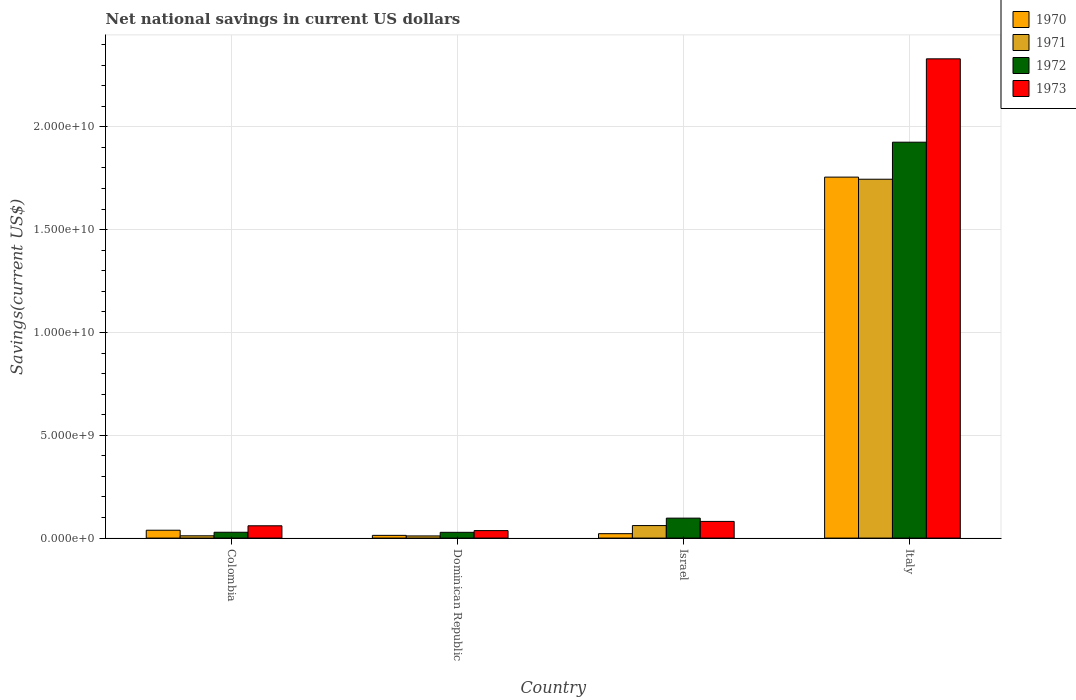How many different coloured bars are there?
Keep it short and to the point. 4. Are the number of bars on each tick of the X-axis equal?
Provide a succinct answer. Yes. How many bars are there on the 3rd tick from the left?
Give a very brief answer. 4. What is the net national savings in 1970 in Colombia?
Your answer should be very brief. 3.83e+08. Across all countries, what is the maximum net national savings in 1970?
Make the answer very short. 1.76e+1. Across all countries, what is the minimum net national savings in 1971?
Offer a very short reply. 1.05e+08. In which country was the net national savings in 1972 maximum?
Provide a succinct answer. Italy. In which country was the net national savings in 1973 minimum?
Provide a short and direct response. Dominican Republic. What is the total net national savings in 1973 in the graph?
Your answer should be very brief. 2.51e+1. What is the difference between the net national savings in 1972 in Colombia and that in Israel?
Offer a terse response. -6.87e+08. What is the difference between the net national savings in 1972 in Colombia and the net national savings in 1970 in Italy?
Your answer should be very brief. -1.73e+1. What is the average net national savings in 1971 per country?
Provide a succinct answer. 4.57e+09. What is the difference between the net national savings of/in 1971 and net national savings of/in 1973 in Dominican Republic?
Your answer should be compact. -2.59e+08. What is the ratio of the net national savings in 1971 in Colombia to that in Israel?
Your response must be concise. 0.18. Is the difference between the net national savings in 1971 in Dominican Republic and Italy greater than the difference between the net national savings in 1973 in Dominican Republic and Italy?
Offer a very short reply. Yes. What is the difference between the highest and the second highest net national savings in 1971?
Provide a succinct answer. 1.68e+1. What is the difference between the highest and the lowest net national savings in 1970?
Make the answer very short. 1.74e+1. What does the 2nd bar from the right in Dominican Republic represents?
Make the answer very short. 1972. Is it the case that in every country, the sum of the net national savings in 1972 and net national savings in 1970 is greater than the net national savings in 1973?
Make the answer very short. Yes. Does the graph contain grids?
Keep it short and to the point. Yes. How are the legend labels stacked?
Provide a short and direct response. Vertical. What is the title of the graph?
Keep it short and to the point. Net national savings in current US dollars. Does "1970" appear as one of the legend labels in the graph?
Keep it short and to the point. Yes. What is the label or title of the Y-axis?
Your answer should be compact. Savings(current US$). What is the Savings(current US$) in 1970 in Colombia?
Offer a very short reply. 3.83e+08. What is the Savings(current US$) in 1971 in Colombia?
Your answer should be compact. 1.11e+08. What is the Savings(current US$) of 1972 in Colombia?
Make the answer very short. 2.84e+08. What is the Savings(current US$) of 1973 in Colombia?
Keep it short and to the point. 5.98e+08. What is the Savings(current US$) of 1970 in Dominican Republic?
Provide a succinct answer. 1.33e+08. What is the Savings(current US$) of 1971 in Dominican Republic?
Keep it short and to the point. 1.05e+08. What is the Savings(current US$) of 1972 in Dominican Republic?
Your answer should be compact. 2.80e+08. What is the Savings(current US$) of 1973 in Dominican Republic?
Keep it short and to the point. 3.65e+08. What is the Savings(current US$) in 1970 in Israel?
Keep it short and to the point. 2.15e+08. What is the Savings(current US$) in 1971 in Israel?
Make the answer very short. 6.09e+08. What is the Savings(current US$) of 1972 in Israel?
Offer a terse response. 9.71e+08. What is the Savings(current US$) of 1973 in Israel?
Your answer should be compact. 8.11e+08. What is the Savings(current US$) of 1970 in Italy?
Your answer should be compact. 1.76e+1. What is the Savings(current US$) in 1971 in Italy?
Make the answer very short. 1.75e+1. What is the Savings(current US$) in 1972 in Italy?
Provide a succinct answer. 1.93e+1. What is the Savings(current US$) of 1973 in Italy?
Make the answer very short. 2.33e+1. Across all countries, what is the maximum Savings(current US$) in 1970?
Offer a very short reply. 1.76e+1. Across all countries, what is the maximum Savings(current US$) in 1971?
Your answer should be very brief. 1.75e+1. Across all countries, what is the maximum Savings(current US$) in 1972?
Your answer should be very brief. 1.93e+1. Across all countries, what is the maximum Savings(current US$) of 1973?
Provide a succinct answer. 2.33e+1. Across all countries, what is the minimum Savings(current US$) of 1970?
Your response must be concise. 1.33e+08. Across all countries, what is the minimum Savings(current US$) in 1971?
Make the answer very short. 1.05e+08. Across all countries, what is the minimum Savings(current US$) of 1972?
Your answer should be very brief. 2.80e+08. Across all countries, what is the minimum Savings(current US$) in 1973?
Provide a short and direct response. 3.65e+08. What is the total Savings(current US$) in 1970 in the graph?
Make the answer very short. 1.83e+1. What is the total Savings(current US$) in 1971 in the graph?
Make the answer very short. 1.83e+1. What is the total Savings(current US$) in 1972 in the graph?
Offer a terse response. 2.08e+1. What is the total Savings(current US$) of 1973 in the graph?
Your answer should be very brief. 2.51e+1. What is the difference between the Savings(current US$) in 1970 in Colombia and that in Dominican Republic?
Provide a short and direct response. 2.50e+08. What is the difference between the Savings(current US$) in 1971 in Colombia and that in Dominican Republic?
Your answer should be compact. 6.03e+06. What is the difference between the Savings(current US$) in 1972 in Colombia and that in Dominican Republic?
Provide a short and direct response. 3.48e+06. What is the difference between the Savings(current US$) of 1973 in Colombia and that in Dominican Republic?
Provide a short and direct response. 2.34e+08. What is the difference between the Savings(current US$) of 1970 in Colombia and that in Israel?
Your answer should be compact. 1.68e+08. What is the difference between the Savings(current US$) in 1971 in Colombia and that in Israel?
Keep it short and to the point. -4.97e+08. What is the difference between the Savings(current US$) in 1972 in Colombia and that in Israel?
Give a very brief answer. -6.87e+08. What is the difference between the Savings(current US$) in 1973 in Colombia and that in Israel?
Ensure brevity in your answer.  -2.12e+08. What is the difference between the Savings(current US$) in 1970 in Colombia and that in Italy?
Keep it short and to the point. -1.72e+1. What is the difference between the Savings(current US$) in 1971 in Colombia and that in Italy?
Ensure brevity in your answer.  -1.73e+1. What is the difference between the Savings(current US$) in 1972 in Colombia and that in Italy?
Ensure brevity in your answer.  -1.90e+1. What is the difference between the Savings(current US$) of 1973 in Colombia and that in Italy?
Keep it short and to the point. -2.27e+1. What is the difference between the Savings(current US$) in 1970 in Dominican Republic and that in Israel?
Ensure brevity in your answer.  -8.19e+07. What is the difference between the Savings(current US$) of 1971 in Dominican Republic and that in Israel?
Offer a very short reply. -5.03e+08. What is the difference between the Savings(current US$) of 1972 in Dominican Republic and that in Israel?
Keep it short and to the point. -6.90e+08. What is the difference between the Savings(current US$) of 1973 in Dominican Republic and that in Israel?
Provide a succinct answer. -4.46e+08. What is the difference between the Savings(current US$) in 1970 in Dominican Republic and that in Italy?
Your answer should be compact. -1.74e+1. What is the difference between the Savings(current US$) in 1971 in Dominican Republic and that in Italy?
Offer a very short reply. -1.73e+1. What is the difference between the Savings(current US$) of 1972 in Dominican Republic and that in Italy?
Ensure brevity in your answer.  -1.90e+1. What is the difference between the Savings(current US$) in 1973 in Dominican Republic and that in Italy?
Your answer should be very brief. -2.29e+1. What is the difference between the Savings(current US$) of 1970 in Israel and that in Italy?
Offer a terse response. -1.73e+1. What is the difference between the Savings(current US$) in 1971 in Israel and that in Italy?
Keep it short and to the point. -1.68e+1. What is the difference between the Savings(current US$) in 1972 in Israel and that in Italy?
Give a very brief answer. -1.83e+1. What is the difference between the Savings(current US$) in 1973 in Israel and that in Italy?
Make the answer very short. -2.25e+1. What is the difference between the Savings(current US$) in 1970 in Colombia and the Savings(current US$) in 1971 in Dominican Republic?
Make the answer very short. 2.77e+08. What is the difference between the Savings(current US$) in 1970 in Colombia and the Savings(current US$) in 1972 in Dominican Republic?
Keep it short and to the point. 1.02e+08. What is the difference between the Savings(current US$) in 1970 in Colombia and the Savings(current US$) in 1973 in Dominican Republic?
Your answer should be very brief. 1.82e+07. What is the difference between the Savings(current US$) in 1971 in Colombia and the Savings(current US$) in 1972 in Dominican Republic?
Provide a succinct answer. -1.69e+08. What is the difference between the Savings(current US$) of 1971 in Colombia and the Savings(current US$) of 1973 in Dominican Republic?
Ensure brevity in your answer.  -2.53e+08. What is the difference between the Savings(current US$) of 1972 in Colombia and the Savings(current US$) of 1973 in Dominican Republic?
Keep it short and to the point. -8.05e+07. What is the difference between the Savings(current US$) in 1970 in Colombia and the Savings(current US$) in 1971 in Israel?
Provide a succinct answer. -2.26e+08. What is the difference between the Savings(current US$) in 1970 in Colombia and the Savings(current US$) in 1972 in Israel?
Offer a terse response. -5.88e+08. What is the difference between the Savings(current US$) in 1970 in Colombia and the Savings(current US$) in 1973 in Israel?
Make the answer very short. -4.28e+08. What is the difference between the Savings(current US$) of 1971 in Colombia and the Savings(current US$) of 1972 in Israel?
Your response must be concise. -8.59e+08. What is the difference between the Savings(current US$) of 1971 in Colombia and the Savings(current US$) of 1973 in Israel?
Provide a short and direct response. -6.99e+08. What is the difference between the Savings(current US$) in 1972 in Colombia and the Savings(current US$) in 1973 in Israel?
Provide a succinct answer. -5.27e+08. What is the difference between the Savings(current US$) in 1970 in Colombia and the Savings(current US$) in 1971 in Italy?
Give a very brief answer. -1.71e+1. What is the difference between the Savings(current US$) in 1970 in Colombia and the Savings(current US$) in 1972 in Italy?
Offer a terse response. -1.89e+1. What is the difference between the Savings(current US$) of 1970 in Colombia and the Savings(current US$) of 1973 in Italy?
Keep it short and to the point. -2.29e+1. What is the difference between the Savings(current US$) in 1971 in Colombia and the Savings(current US$) in 1972 in Italy?
Provide a short and direct response. -1.91e+1. What is the difference between the Savings(current US$) in 1971 in Colombia and the Savings(current US$) in 1973 in Italy?
Your response must be concise. -2.32e+1. What is the difference between the Savings(current US$) in 1972 in Colombia and the Savings(current US$) in 1973 in Italy?
Keep it short and to the point. -2.30e+1. What is the difference between the Savings(current US$) in 1970 in Dominican Republic and the Savings(current US$) in 1971 in Israel?
Ensure brevity in your answer.  -4.76e+08. What is the difference between the Savings(current US$) in 1970 in Dominican Republic and the Savings(current US$) in 1972 in Israel?
Offer a very short reply. -8.38e+08. What is the difference between the Savings(current US$) of 1970 in Dominican Republic and the Savings(current US$) of 1973 in Israel?
Your answer should be very brief. -6.78e+08. What is the difference between the Savings(current US$) in 1971 in Dominican Republic and the Savings(current US$) in 1972 in Israel?
Your answer should be very brief. -8.65e+08. What is the difference between the Savings(current US$) in 1971 in Dominican Republic and the Savings(current US$) in 1973 in Israel?
Your answer should be very brief. -7.05e+08. What is the difference between the Savings(current US$) in 1972 in Dominican Republic and the Savings(current US$) in 1973 in Israel?
Ensure brevity in your answer.  -5.30e+08. What is the difference between the Savings(current US$) of 1970 in Dominican Republic and the Savings(current US$) of 1971 in Italy?
Provide a succinct answer. -1.73e+1. What is the difference between the Savings(current US$) in 1970 in Dominican Republic and the Savings(current US$) in 1972 in Italy?
Your answer should be compact. -1.91e+1. What is the difference between the Savings(current US$) in 1970 in Dominican Republic and the Savings(current US$) in 1973 in Italy?
Make the answer very short. -2.32e+1. What is the difference between the Savings(current US$) in 1971 in Dominican Republic and the Savings(current US$) in 1972 in Italy?
Keep it short and to the point. -1.91e+1. What is the difference between the Savings(current US$) of 1971 in Dominican Republic and the Savings(current US$) of 1973 in Italy?
Offer a terse response. -2.32e+1. What is the difference between the Savings(current US$) of 1972 in Dominican Republic and the Savings(current US$) of 1973 in Italy?
Your response must be concise. -2.30e+1. What is the difference between the Savings(current US$) in 1970 in Israel and the Savings(current US$) in 1971 in Italy?
Provide a succinct answer. -1.72e+1. What is the difference between the Savings(current US$) of 1970 in Israel and the Savings(current US$) of 1972 in Italy?
Ensure brevity in your answer.  -1.90e+1. What is the difference between the Savings(current US$) of 1970 in Israel and the Savings(current US$) of 1973 in Italy?
Provide a short and direct response. -2.31e+1. What is the difference between the Savings(current US$) of 1971 in Israel and the Savings(current US$) of 1972 in Italy?
Keep it short and to the point. -1.86e+1. What is the difference between the Savings(current US$) in 1971 in Israel and the Savings(current US$) in 1973 in Italy?
Keep it short and to the point. -2.27e+1. What is the difference between the Savings(current US$) in 1972 in Israel and the Savings(current US$) in 1973 in Italy?
Your answer should be very brief. -2.23e+1. What is the average Savings(current US$) in 1970 per country?
Make the answer very short. 4.57e+09. What is the average Savings(current US$) of 1971 per country?
Keep it short and to the point. 4.57e+09. What is the average Savings(current US$) of 1972 per country?
Offer a terse response. 5.20e+09. What is the average Savings(current US$) of 1973 per country?
Give a very brief answer. 6.27e+09. What is the difference between the Savings(current US$) of 1970 and Savings(current US$) of 1971 in Colombia?
Offer a terse response. 2.71e+08. What is the difference between the Savings(current US$) of 1970 and Savings(current US$) of 1972 in Colombia?
Your answer should be compact. 9.87e+07. What is the difference between the Savings(current US$) in 1970 and Savings(current US$) in 1973 in Colombia?
Your response must be concise. -2.16e+08. What is the difference between the Savings(current US$) of 1971 and Savings(current US$) of 1972 in Colombia?
Keep it short and to the point. -1.73e+08. What is the difference between the Savings(current US$) in 1971 and Savings(current US$) in 1973 in Colombia?
Offer a very short reply. -4.87e+08. What is the difference between the Savings(current US$) in 1972 and Savings(current US$) in 1973 in Colombia?
Your answer should be compact. -3.14e+08. What is the difference between the Savings(current US$) of 1970 and Savings(current US$) of 1971 in Dominican Republic?
Ensure brevity in your answer.  2.74e+07. What is the difference between the Savings(current US$) of 1970 and Savings(current US$) of 1972 in Dominican Republic?
Your answer should be compact. -1.48e+08. What is the difference between the Savings(current US$) of 1970 and Savings(current US$) of 1973 in Dominican Republic?
Ensure brevity in your answer.  -2.32e+08. What is the difference between the Savings(current US$) of 1971 and Savings(current US$) of 1972 in Dominican Republic?
Ensure brevity in your answer.  -1.75e+08. What is the difference between the Savings(current US$) of 1971 and Savings(current US$) of 1973 in Dominican Republic?
Ensure brevity in your answer.  -2.59e+08. What is the difference between the Savings(current US$) of 1972 and Savings(current US$) of 1973 in Dominican Republic?
Ensure brevity in your answer.  -8.40e+07. What is the difference between the Savings(current US$) in 1970 and Savings(current US$) in 1971 in Israel?
Ensure brevity in your answer.  -3.94e+08. What is the difference between the Savings(current US$) of 1970 and Savings(current US$) of 1972 in Israel?
Keep it short and to the point. -7.56e+08. What is the difference between the Savings(current US$) in 1970 and Savings(current US$) in 1973 in Israel?
Your response must be concise. -5.96e+08. What is the difference between the Savings(current US$) of 1971 and Savings(current US$) of 1972 in Israel?
Offer a terse response. -3.62e+08. What is the difference between the Savings(current US$) of 1971 and Savings(current US$) of 1973 in Israel?
Your answer should be compact. -2.02e+08. What is the difference between the Savings(current US$) of 1972 and Savings(current US$) of 1973 in Israel?
Make the answer very short. 1.60e+08. What is the difference between the Savings(current US$) of 1970 and Savings(current US$) of 1971 in Italy?
Your answer should be very brief. 1.03e+08. What is the difference between the Savings(current US$) in 1970 and Savings(current US$) in 1972 in Italy?
Your answer should be compact. -1.70e+09. What is the difference between the Savings(current US$) of 1970 and Savings(current US$) of 1973 in Italy?
Offer a terse response. -5.75e+09. What is the difference between the Savings(current US$) of 1971 and Savings(current US$) of 1972 in Italy?
Make the answer very short. -1.80e+09. What is the difference between the Savings(current US$) in 1971 and Savings(current US$) in 1973 in Italy?
Ensure brevity in your answer.  -5.86e+09. What is the difference between the Savings(current US$) in 1972 and Savings(current US$) in 1973 in Italy?
Provide a short and direct response. -4.05e+09. What is the ratio of the Savings(current US$) of 1970 in Colombia to that in Dominican Republic?
Give a very brief answer. 2.88. What is the ratio of the Savings(current US$) of 1971 in Colombia to that in Dominican Republic?
Provide a succinct answer. 1.06. What is the ratio of the Savings(current US$) of 1972 in Colombia to that in Dominican Republic?
Keep it short and to the point. 1.01. What is the ratio of the Savings(current US$) in 1973 in Colombia to that in Dominican Republic?
Ensure brevity in your answer.  1.64. What is the ratio of the Savings(current US$) in 1970 in Colombia to that in Israel?
Offer a terse response. 1.78. What is the ratio of the Savings(current US$) in 1971 in Colombia to that in Israel?
Provide a short and direct response. 0.18. What is the ratio of the Savings(current US$) of 1972 in Colombia to that in Israel?
Offer a very short reply. 0.29. What is the ratio of the Savings(current US$) in 1973 in Colombia to that in Israel?
Offer a very short reply. 0.74. What is the ratio of the Savings(current US$) in 1970 in Colombia to that in Italy?
Your response must be concise. 0.02. What is the ratio of the Savings(current US$) in 1971 in Colombia to that in Italy?
Ensure brevity in your answer.  0.01. What is the ratio of the Savings(current US$) in 1972 in Colombia to that in Italy?
Offer a very short reply. 0.01. What is the ratio of the Savings(current US$) of 1973 in Colombia to that in Italy?
Keep it short and to the point. 0.03. What is the ratio of the Savings(current US$) in 1970 in Dominican Republic to that in Israel?
Your answer should be very brief. 0.62. What is the ratio of the Savings(current US$) of 1971 in Dominican Republic to that in Israel?
Offer a very short reply. 0.17. What is the ratio of the Savings(current US$) in 1972 in Dominican Republic to that in Israel?
Offer a terse response. 0.29. What is the ratio of the Savings(current US$) of 1973 in Dominican Republic to that in Israel?
Ensure brevity in your answer.  0.45. What is the ratio of the Savings(current US$) in 1970 in Dominican Republic to that in Italy?
Your response must be concise. 0.01. What is the ratio of the Savings(current US$) of 1971 in Dominican Republic to that in Italy?
Ensure brevity in your answer.  0.01. What is the ratio of the Savings(current US$) in 1972 in Dominican Republic to that in Italy?
Provide a succinct answer. 0.01. What is the ratio of the Savings(current US$) in 1973 in Dominican Republic to that in Italy?
Your answer should be compact. 0.02. What is the ratio of the Savings(current US$) of 1970 in Israel to that in Italy?
Provide a succinct answer. 0.01. What is the ratio of the Savings(current US$) of 1971 in Israel to that in Italy?
Offer a terse response. 0.03. What is the ratio of the Savings(current US$) in 1972 in Israel to that in Italy?
Your answer should be compact. 0.05. What is the ratio of the Savings(current US$) of 1973 in Israel to that in Italy?
Offer a very short reply. 0.03. What is the difference between the highest and the second highest Savings(current US$) of 1970?
Your answer should be very brief. 1.72e+1. What is the difference between the highest and the second highest Savings(current US$) in 1971?
Provide a succinct answer. 1.68e+1. What is the difference between the highest and the second highest Savings(current US$) of 1972?
Keep it short and to the point. 1.83e+1. What is the difference between the highest and the second highest Savings(current US$) in 1973?
Keep it short and to the point. 2.25e+1. What is the difference between the highest and the lowest Savings(current US$) in 1970?
Offer a very short reply. 1.74e+1. What is the difference between the highest and the lowest Savings(current US$) in 1971?
Offer a very short reply. 1.73e+1. What is the difference between the highest and the lowest Savings(current US$) in 1972?
Give a very brief answer. 1.90e+1. What is the difference between the highest and the lowest Savings(current US$) in 1973?
Your response must be concise. 2.29e+1. 